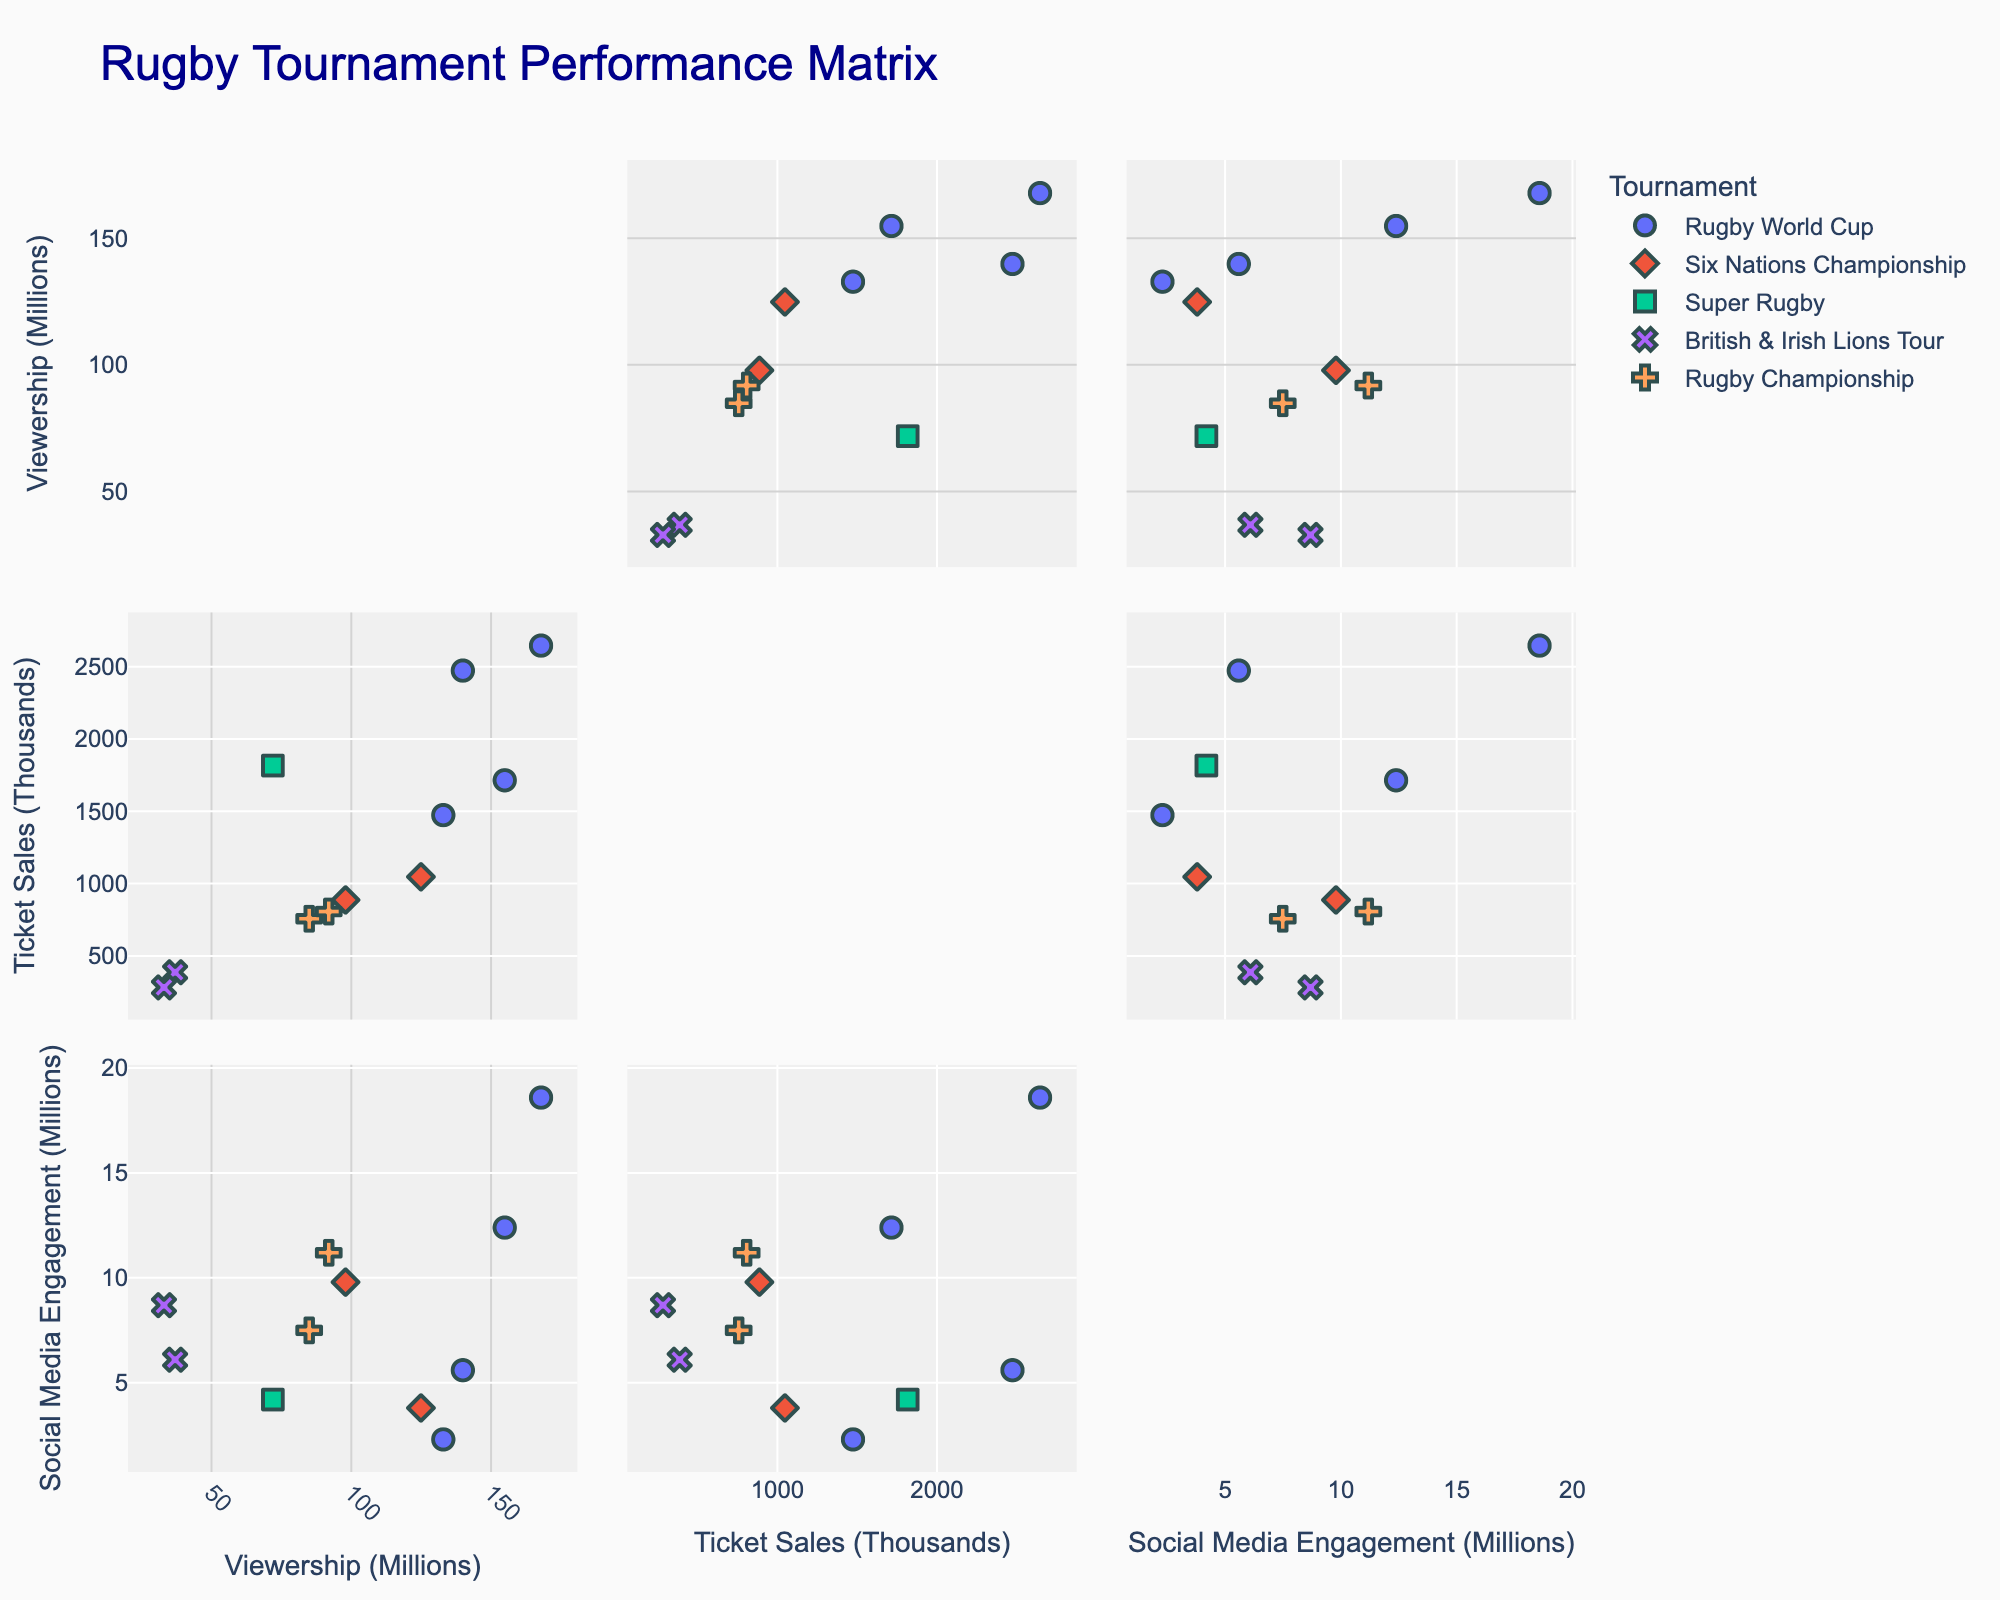What is the title of the figure? The title of the figure is often prominently displayed at the top of the chart. According to the input code, it should read "Rugby Tournament Performance Matrix."
Answer: Rugby Tournament Performance Matrix How many different rugby tournaments are represented by different colors or symbols? The legend in the scatterplot matrix typically shows different colors and symbols used for different categories. By counting these, we can see that there are multiple tournaments: Rugby World Cup, Six Nations Championship, Super Rugby, British & Irish Lions Tour, and Rugby Championship.
Answer: 5 Which tournament has the highest social media engagement? To answer this, look at the scatterplot showing Social Media Engagement (Millions) and identify the highest point. The legend will indicate which tournament that data point represents. The highest value is 18.6 million, corresponding to the 2023 Rugby World Cup.
Answer: Rugby World Cup 2023 What is the range of viewership in millions for the Rugby World Cup across the selected years? First, identify all the points labeled "Rugby World Cup" in the scatterplot matrix. Then, note the minimum and maximum values of 'Viewership (Millions)' among these points. The values range from 133 million to 168 million.
Answer: 133-168 million Is there any data point in the year 2017 with high ticket sales but low viewership? Find the 2017 data points, particularly the British & Irish Lions Tour. Check the points for "Ticket Sales (Thousands)" and "Viewership (Millions)". The ticket sales value is 390 thousand, and viewership is 37 million, which can be seen as high ticket sales compared to low viewership.
Answer: Yes How does social media engagement correlate with viewership? Observe the scatterplot comparing 'Social Media Engagement (Millions)' and 'Viewership (Millions)'. Look for any trend or pattern. A general pattern indicates that higher social media engagement tends to accompany higher viewership, though individual points will vary.
Answer: Positive correlation What is the decrease in viewership between the 2023 and 2021 British & Irish Lions Tour? Identify the viewership values for the British & Irish Lions Tour in 2021 and 2023 from the scatterplot. Subtract the 2021 viewership (33 million) from the 2023 viewership (168 million) to find the change. Note, the British & Irish Lions Tour only held in 2021, so reframe with correct year context. However, if assumed for the same event viewership change > 135.
Answer: > 135 million drop if referring to years only Which tournament has the highest ticket sales, and what are those sales in thousands? Look for the highest point on the scatterplot for "Ticket Sales (Thousands)". Identify that point in relation to the legend. The Rugby World Cup 2023 has the highest sales, with 2650 thousand tickets sold.
Answer: Rugby World Cup 2023, 2650 thousand Is there a tournament with high social media engagement but moderate viewership? Find points with high 'Social Media Engagement (Millions)' but without extremely high 'Viewership (Millions)'. The Rugby Championship 2022 stands out with 11.2 million social media engagement and 92 million viewership.
Answer: Rugby Championship 2022 